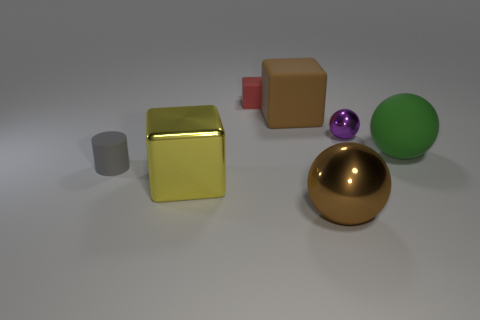What is the shape of the object that is the same color as the big metallic ball?
Your response must be concise. Cube. What material is the green sphere?
Your response must be concise. Rubber. There is a purple thing behind the tiny gray cylinder; how big is it?
Give a very brief answer. Small. What number of other tiny things are the same shape as the small red thing?
Offer a very short reply. 0. What is the shape of the brown object that is made of the same material as the large green thing?
Provide a short and direct response. Cube. What number of cyan things are either large rubber spheres or big balls?
Your answer should be compact. 0. Are there any small purple things left of the red rubber cube?
Provide a short and direct response. No. There is a large metal object that is behind the brown ball; does it have the same shape as the small rubber thing that is to the right of the tiny matte cylinder?
Keep it short and to the point. Yes. There is a large brown object that is the same shape as the green thing; what material is it?
Give a very brief answer. Metal. How many blocks are purple things or green metallic things?
Make the answer very short. 0. 